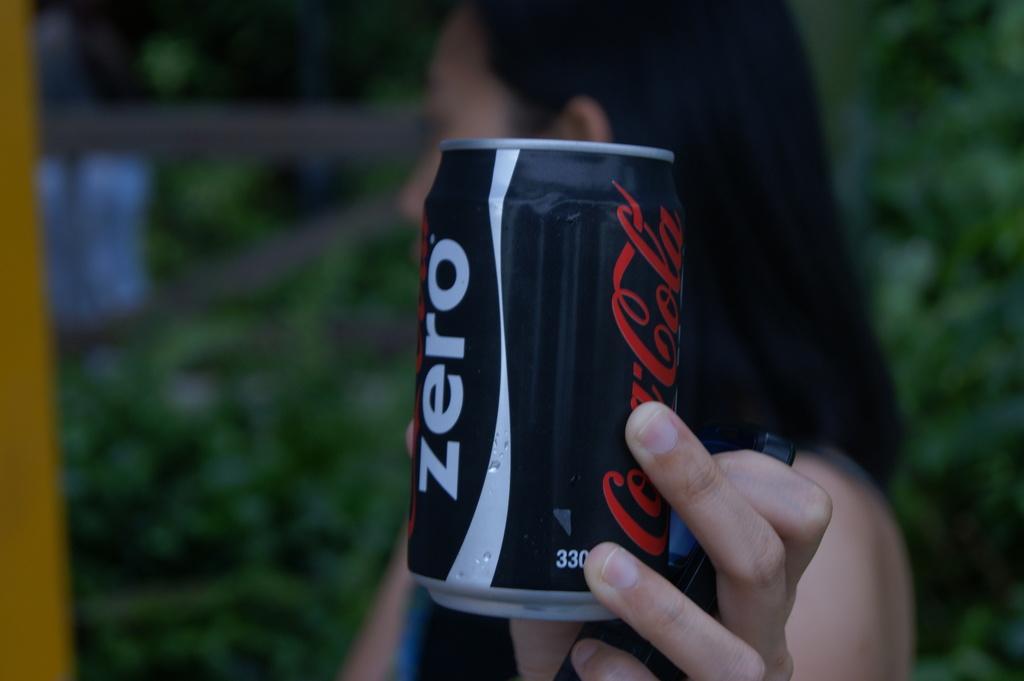In one or two sentences, can you explain what this image depicts? Inn this image I can see a woman holding a black color coke tin , on coke tin I can see a text and woman holding a mobile on her hand and background is too blur. 